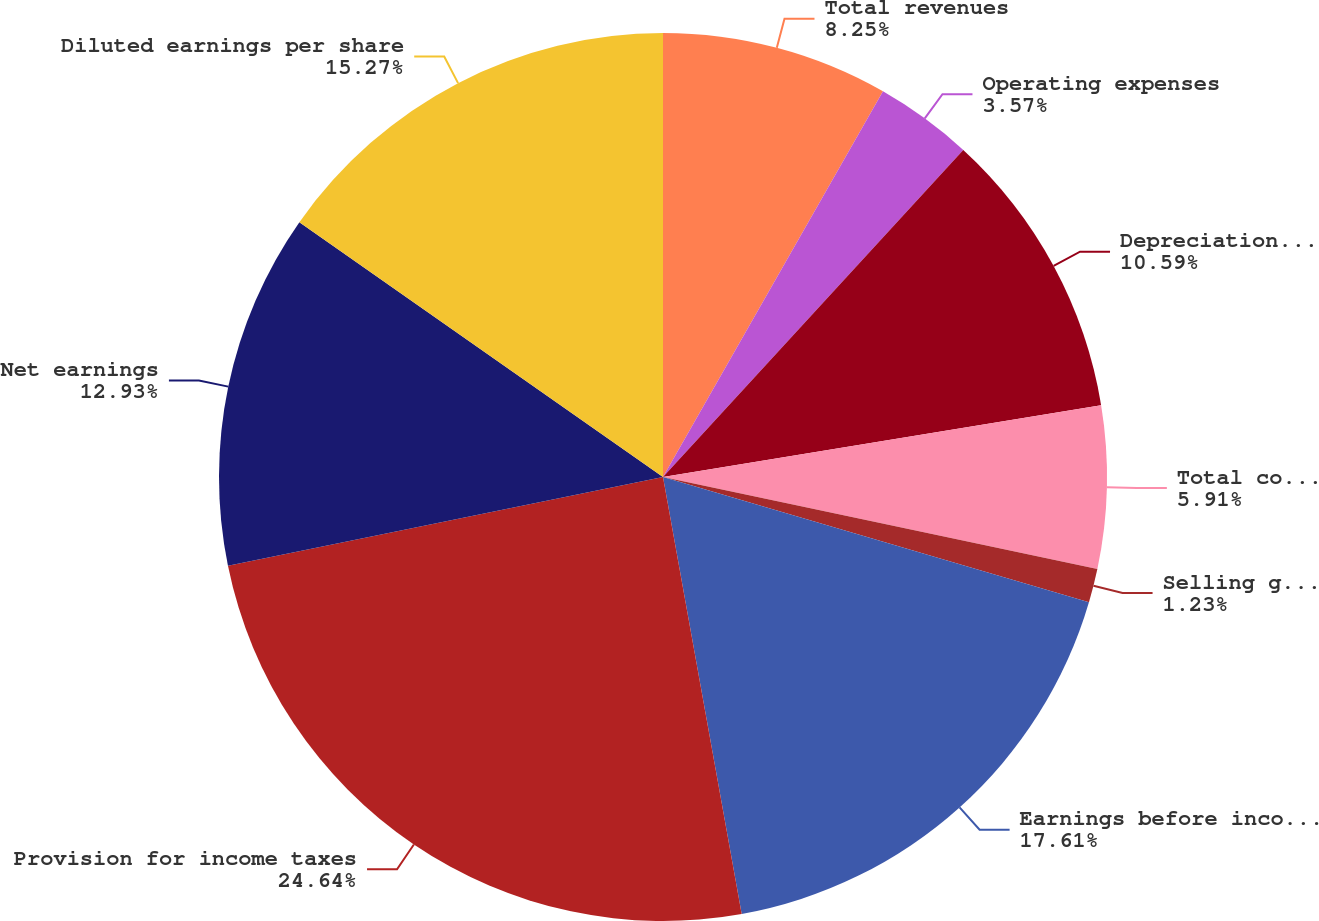<chart> <loc_0><loc_0><loc_500><loc_500><pie_chart><fcel>Total revenues<fcel>Operating expenses<fcel>Depreciation and amortization<fcel>Total costs of revenues<fcel>Selling general and<fcel>Earnings before income taxes<fcel>Provision for income taxes<fcel>Net earnings<fcel>Diluted earnings per share<nl><fcel>8.25%<fcel>3.57%<fcel>10.59%<fcel>5.91%<fcel>1.23%<fcel>17.61%<fcel>24.63%<fcel>12.93%<fcel>15.27%<nl></chart> 